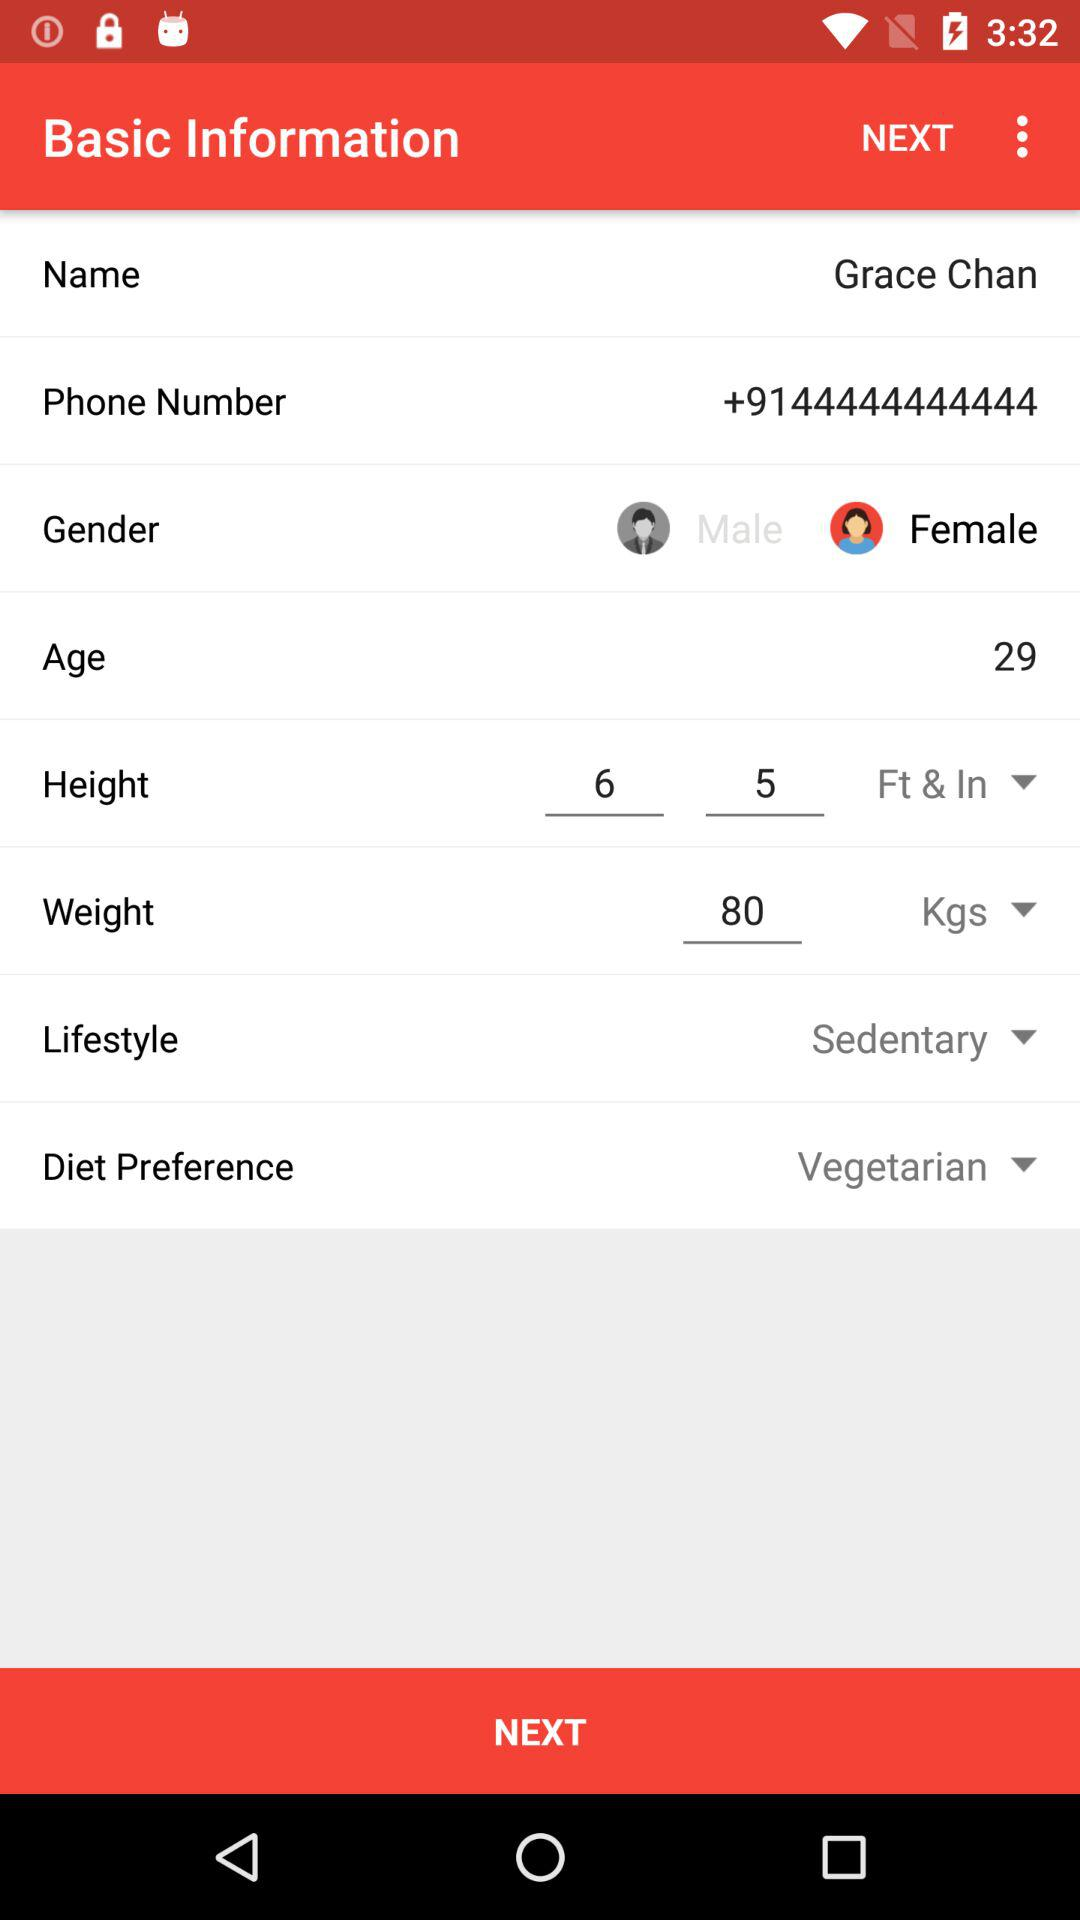What is the lifestyle of the user? The lifestyle of the user is sedentary. 